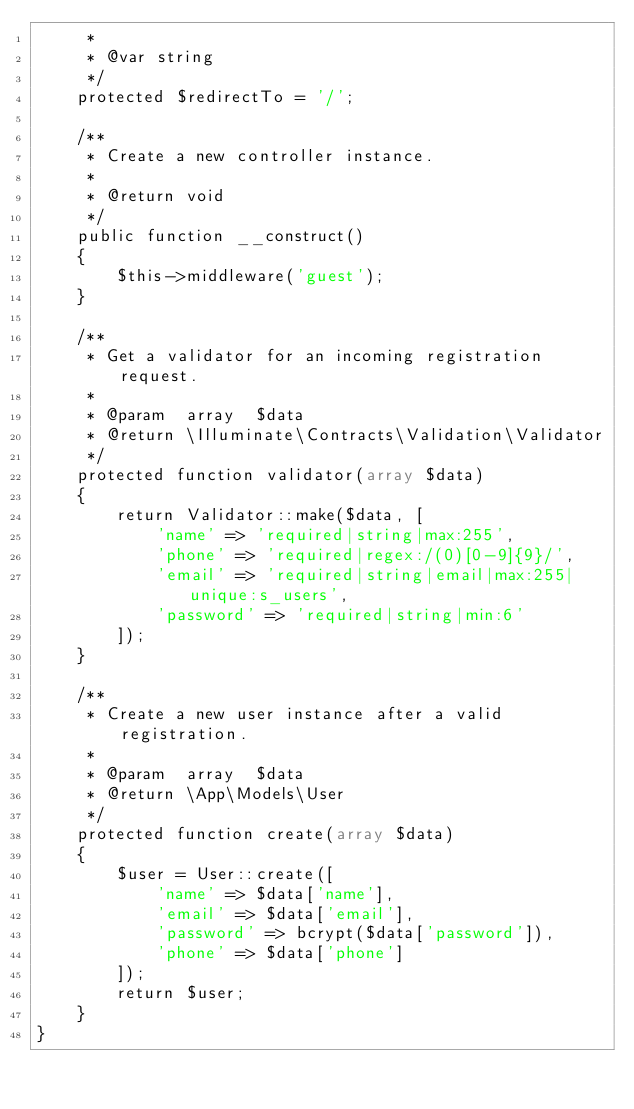Convert code to text. <code><loc_0><loc_0><loc_500><loc_500><_PHP_>     *
     * @var string
     */
    protected $redirectTo = '/';

    /**
     * Create a new controller instance.
     *
     * @return void
     */
    public function __construct()
    {
        $this->middleware('guest');
    }

    /**
     * Get a validator for an incoming registration request.
     *
     * @param  array  $data
     * @return \Illuminate\Contracts\Validation\Validator
     */
    protected function validator(array $data)
    {
        return Validator::make($data, [
            'name' => 'required|string|max:255',
            'phone' => 'required|regex:/(0)[0-9]{9}/',
            'email' => 'required|string|email|max:255|unique:s_users',
            'password' => 'required|string|min:6'
        ]);
    }

    /**
     * Create a new user instance after a valid registration.
     *
     * @param  array  $data
     * @return \App\Models\User
     */
    protected function create(array $data)
    {
        $user = User::create([
            'name' => $data['name'],
            'email' => $data['email'],
            'password' => bcrypt($data['password']),
            'phone' => $data['phone']
        ]);
        return $user;
    }
}
</code> 